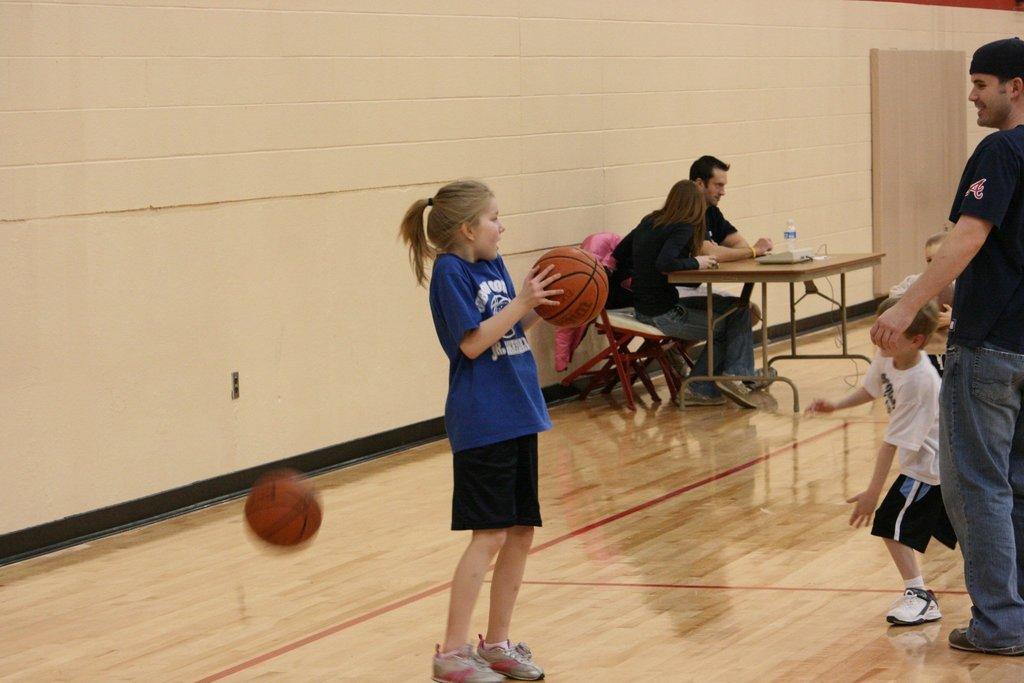Describe this image in one or two sentences. It seems to be the image is taken in a foot ball court. In middle there is a girl holding a foot ball, on right side there are group of people standing and we can also see two people man and woman are sitting on chair in front of a table. On table we can see a water bottle,tray and bowl. In background there is a wall which is in cream color. 